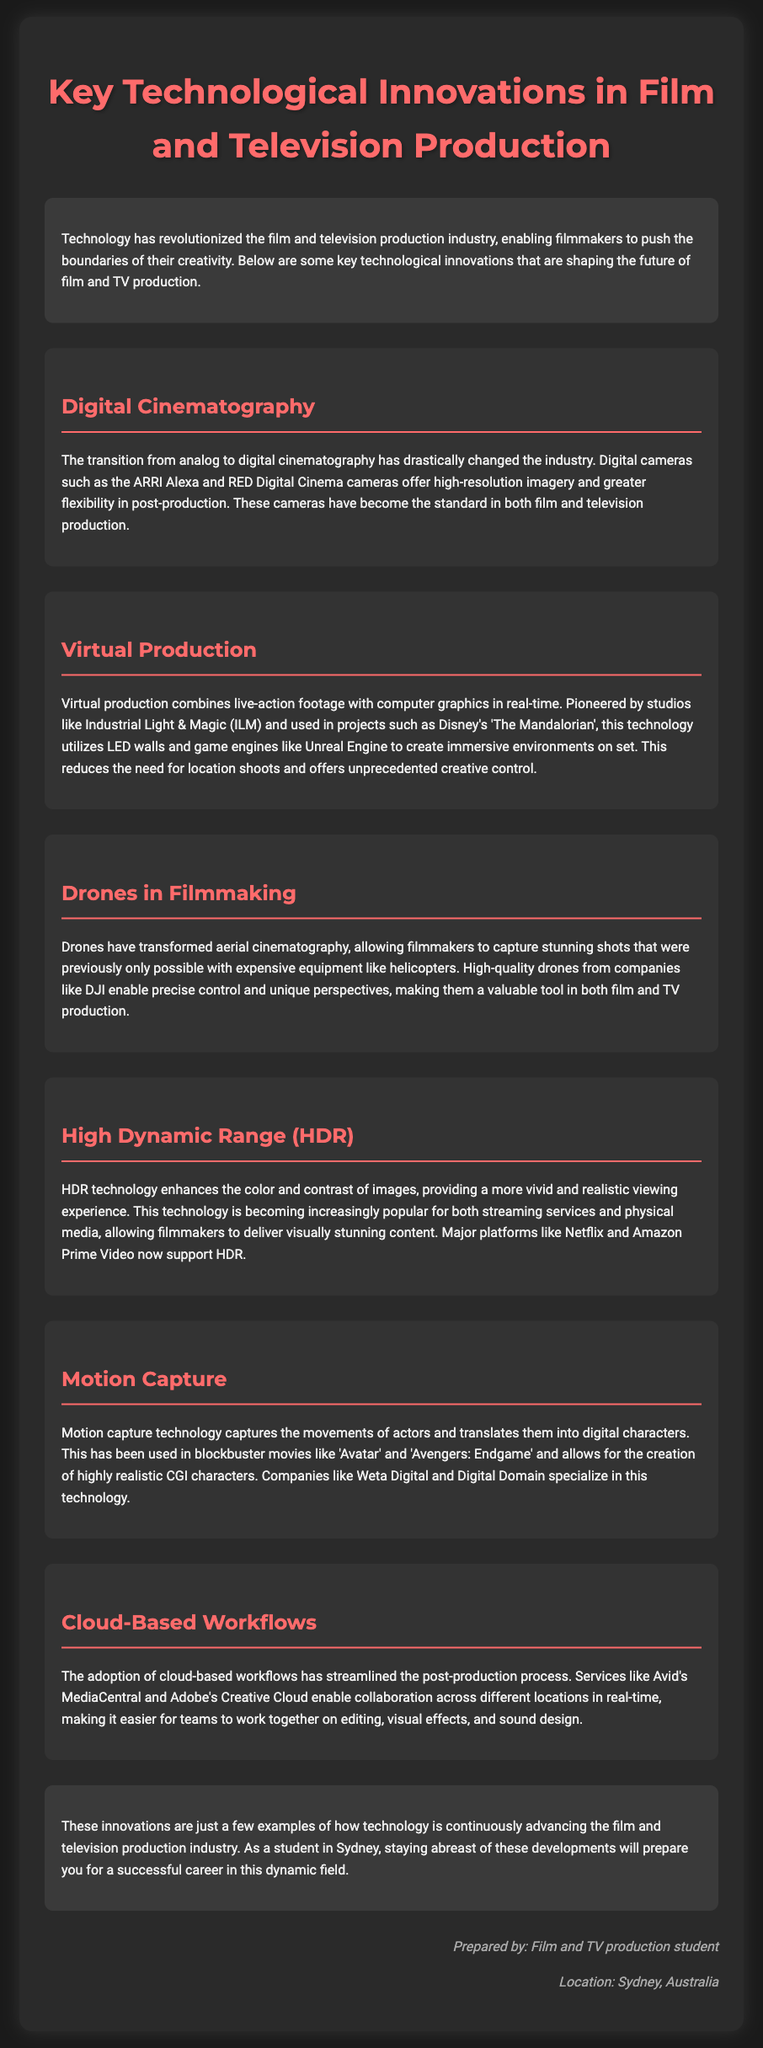What is the first technological innovation mentioned? The first innovation discussed in the document is Digital Cinematography, highlighting its impact on the industry.
Answer: Digital Cinematography Who pioneered virtual production technology? The document states that studios like Industrial Light & Magic (ILM) have pioneered virtual production technology.
Answer: Industrial Light & Magic What technology is used for creating immersive environments in virtual production? The document mentions that LED walls and game engines like Unreal Engine are utilized in virtual production to create immersive environments.
Answer: LED walls and Unreal Engine Which company is noted for transforming aerial cinematography with drones? The document references high-quality drones from the company DJI as significant in transforming aerial cinematography.
Answer: DJI What does HDR stand for? The technology discussed is abbreviated as HDR, which enhances the color and contrast of images.
Answer: High Dynamic Range In which movies has motion capture technology been used? The document lists blockbuster movies like 'Avatar' and 'Avengers: Endgame' as examples where motion capture technology has been applied.
Answer: Avatar and Avengers: Endgame What type of workflows are being adopted to streamline post-production? The document indicates that cloud-based workflows are being adopted to improve the post-production process.
Answer: Cloud-Based Workflows What main benefit does cloud-based workflows provide? According to the document, cloud-based workflows enable collaboration across different locations in real-time.
Answer: Collaboration in real-time What is the significance of staying updated with technological innovations for film and TV production students? The document emphasizes that staying abreast of technological innovations prepares students for successful careers in the evolving industry.
Answer: Successful careers in the evolving industry 